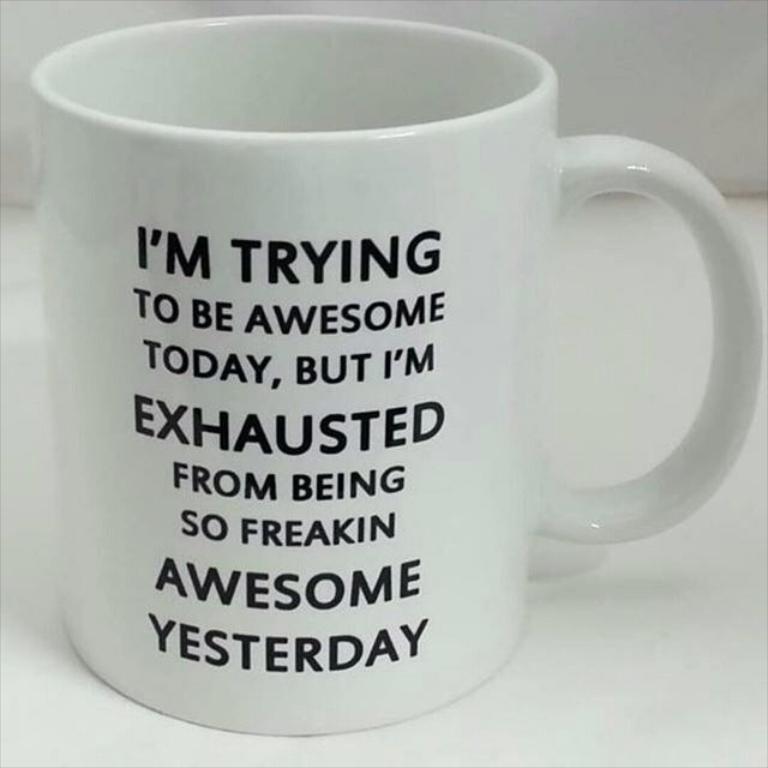What does the coffee mug say the person is trying to be today?
Your answer should be very brief. Awesome. What is the bottom word on the mug?
Keep it short and to the point. Yesterday. 